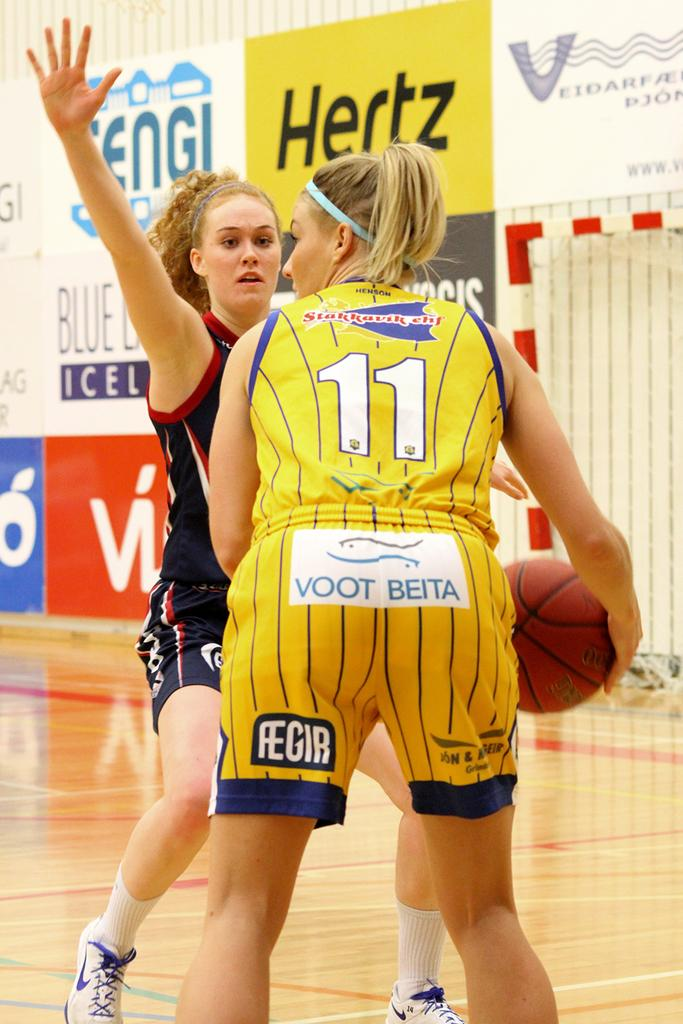<image>
Create a compact narrative representing the image presented. a Hertz ad next to a basketball game with girls 